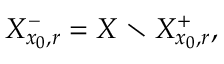<formula> <loc_0><loc_0><loc_500><loc_500>X _ { x _ { 0 } , r } ^ { - } = X \ X _ { x _ { 0 } , r } ^ { + } ,</formula> 